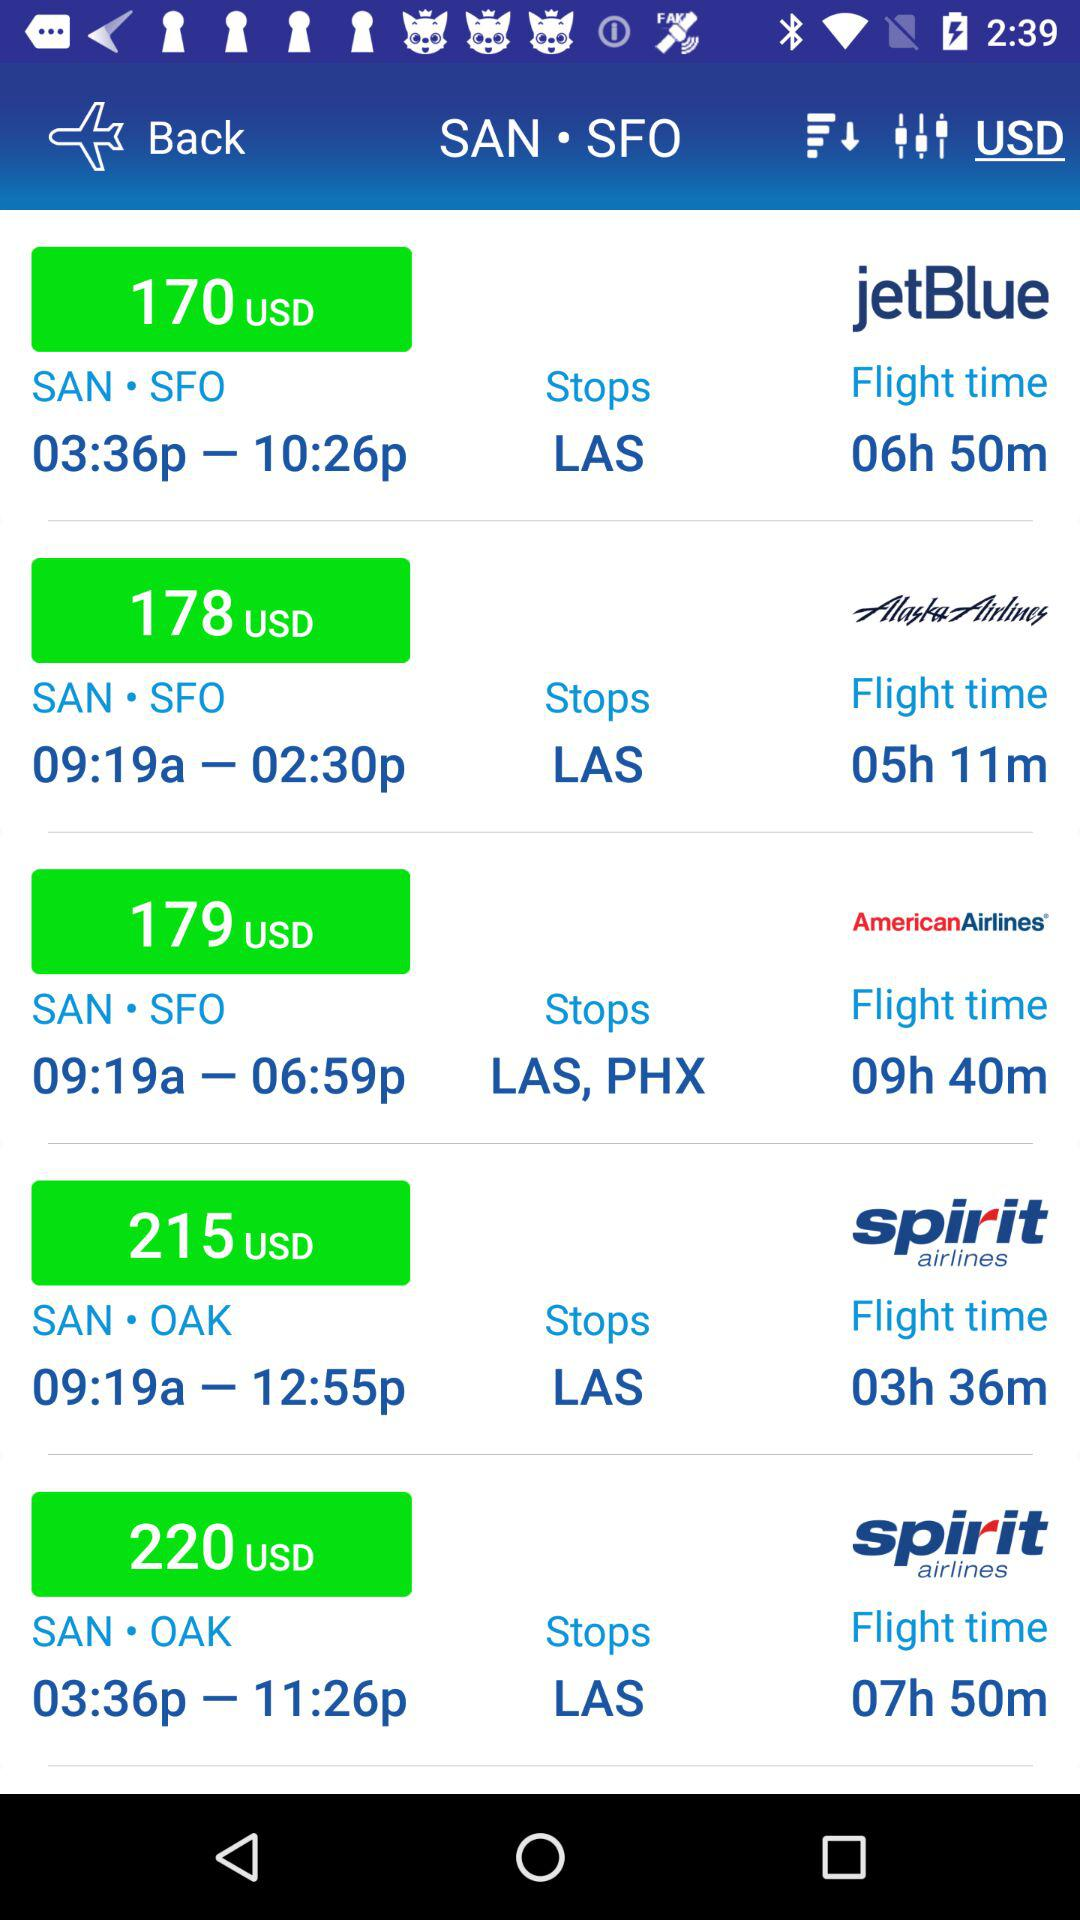Which airline ticket is the price of 220 USD? The airline ticket that has a price of 220 USD is "spirit airlines". 